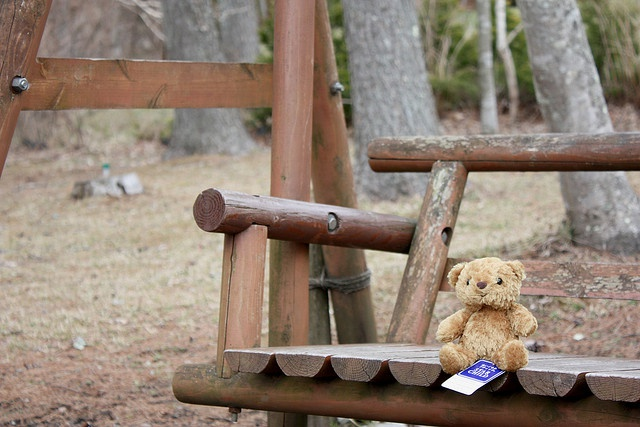Describe the objects in this image and their specific colors. I can see bench in gray, darkgray, and black tones and teddy bear in gray and tan tones in this image. 